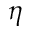<formula> <loc_0><loc_0><loc_500><loc_500>\eta</formula> 